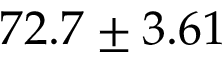<formula> <loc_0><loc_0><loc_500><loc_500>7 2 . 7 \pm 3 . 6 1</formula> 